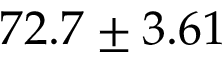<formula> <loc_0><loc_0><loc_500><loc_500>7 2 . 7 \pm 3 . 6 1</formula> 